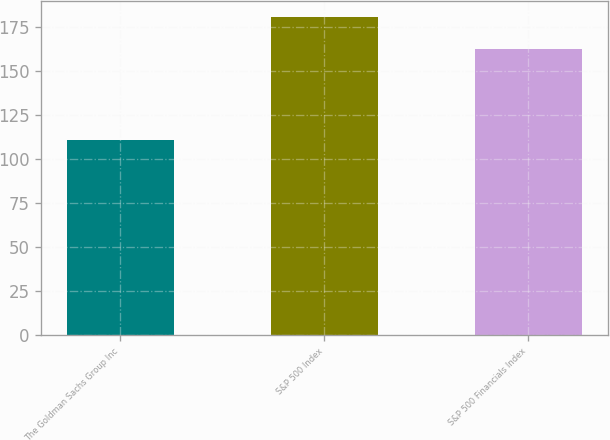Convert chart. <chart><loc_0><loc_0><loc_500><loc_500><bar_chart><fcel>The Goldman Sachs Group Inc<fcel>S&P 500 Index<fcel>S&P 500 Financials Index<nl><fcel>110.39<fcel>180.4<fcel>162.34<nl></chart> 